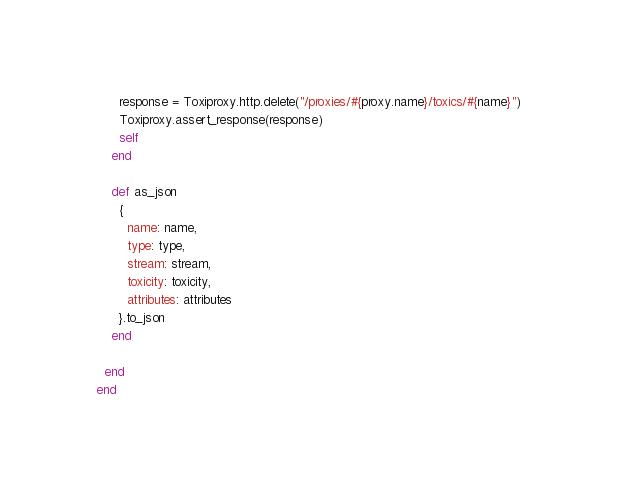Convert code to text. <code><loc_0><loc_0><loc_500><loc_500><_Crystal_>      response = Toxiproxy.http.delete("/proxies/#{proxy.name}/toxics/#{name}")
      Toxiproxy.assert_response(response)
      self
    end

    def as_json
      {
        name: name,
        type: type,
        stream: stream,
        toxicity: toxicity,
        attributes: attributes
      }.to_json
    end

  end
end
</code> 